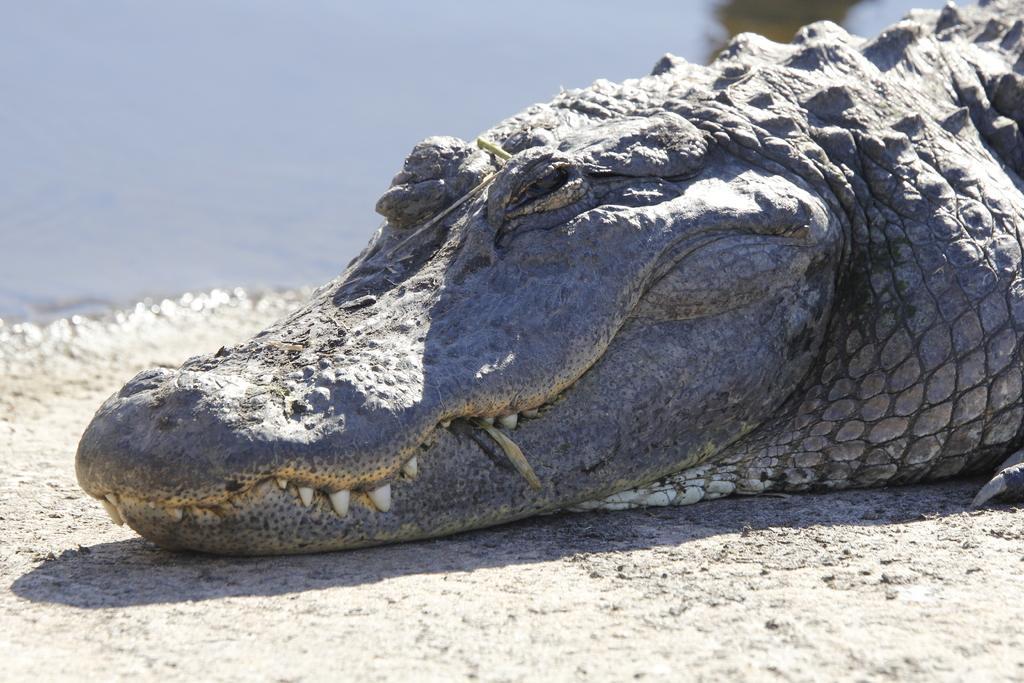Can you describe this image briefly? In this image we can see a crocodile on the surface. In the background we can see the water. 